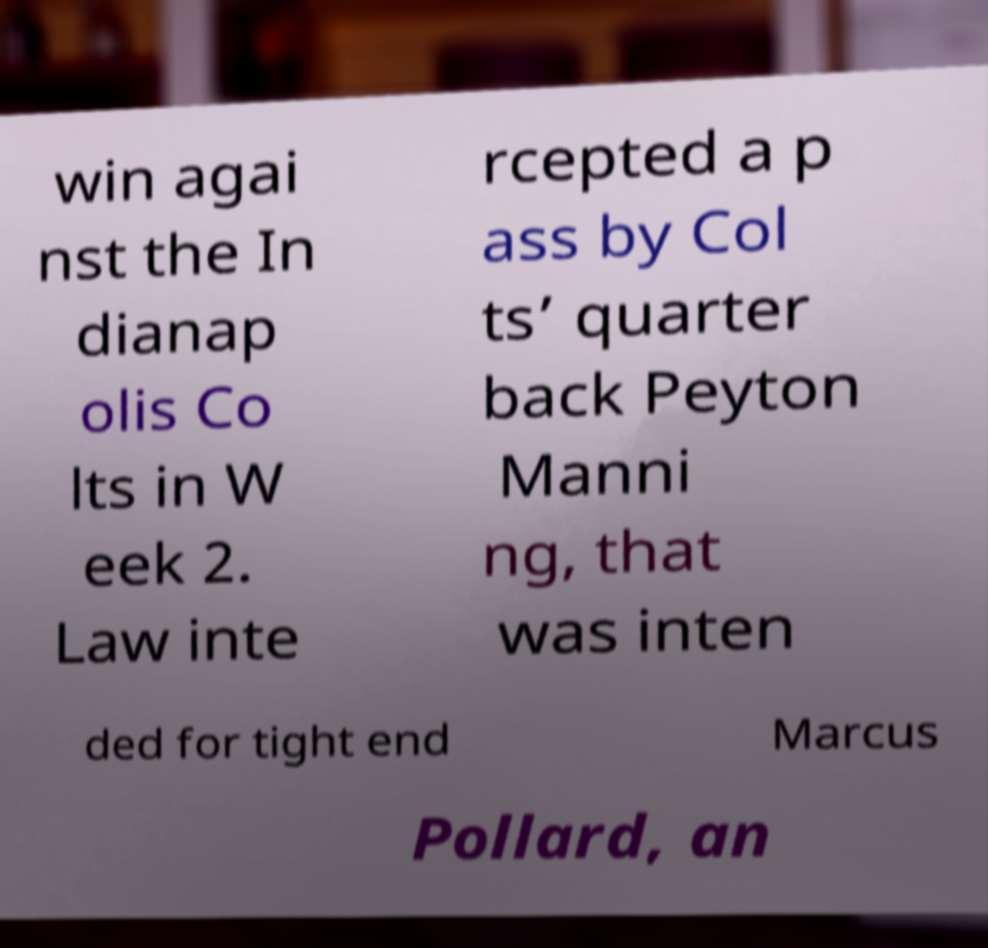For documentation purposes, I need the text within this image transcribed. Could you provide that? win agai nst the In dianap olis Co lts in W eek 2. Law inte rcepted a p ass by Col ts’ quarter back Peyton Manni ng, that was inten ded for tight end Marcus Pollard, an 